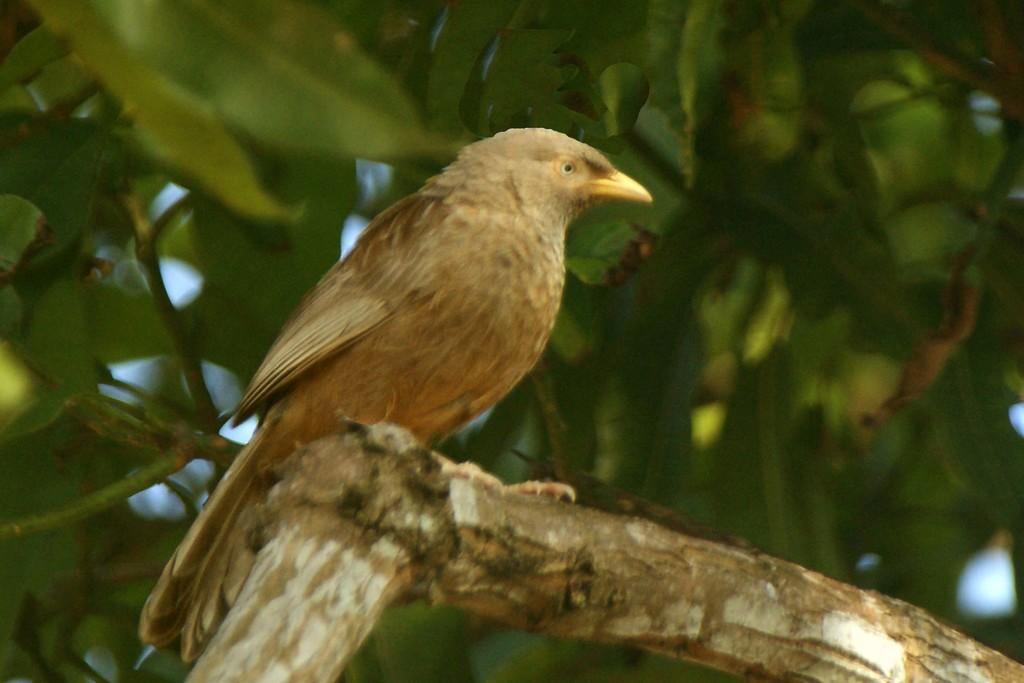What type of animal is in the image? There is a bird in the image. Where is the bird located? The bird is on a tree. What can be seen in the background of the image? There are leaves visible in the background of the image. Can you see a woman flying an airplane in the image? No, there is no woman or airplane present in the image. Are there any icicles hanging from the tree in the image? No, there are no icicles visible in the image. 